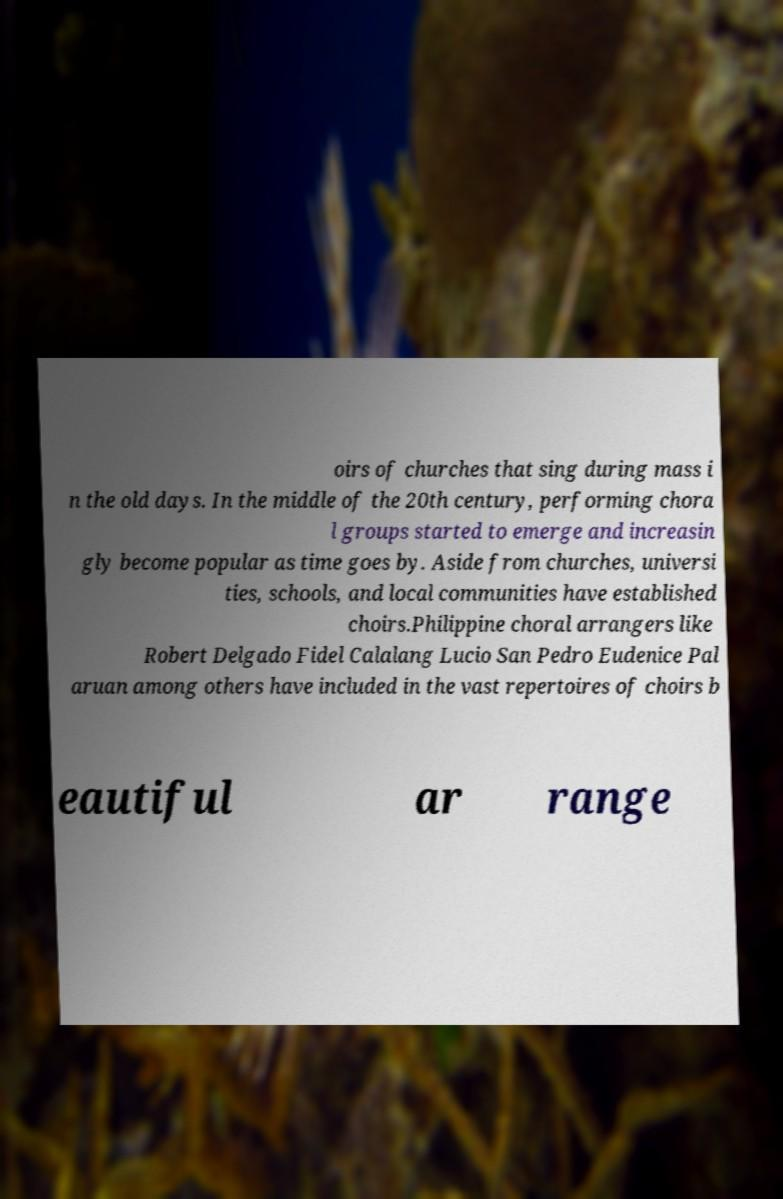I need the written content from this picture converted into text. Can you do that? oirs of churches that sing during mass i n the old days. In the middle of the 20th century, performing chora l groups started to emerge and increasin gly become popular as time goes by. Aside from churches, universi ties, schools, and local communities have established choirs.Philippine choral arrangers like Robert Delgado Fidel Calalang Lucio San Pedro Eudenice Pal aruan among others have included in the vast repertoires of choirs b eautiful ar range 